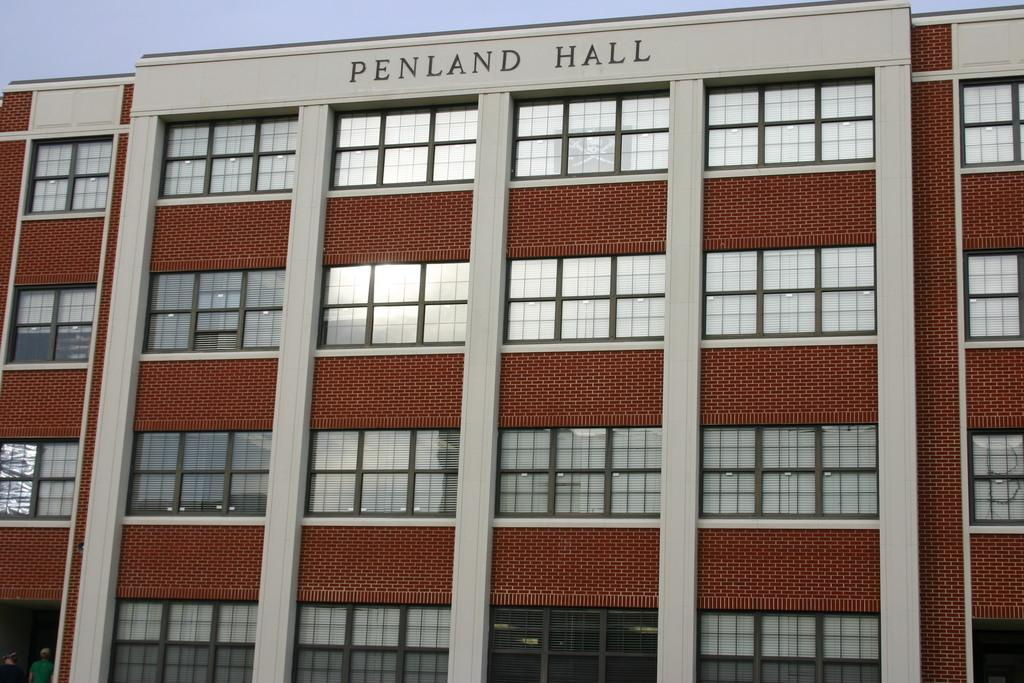What is the name of the building in the image? There is a building with a name in the image. How many people are present in the image? There are two people in the image. What can be seen in the background of the image? The sky is visible in the background of the image. Where is the garden located in the image? There is no garden present in the image. What color is the tongue of the person on the left? There is no tongue visible in the image, as the people are fully clothed. 